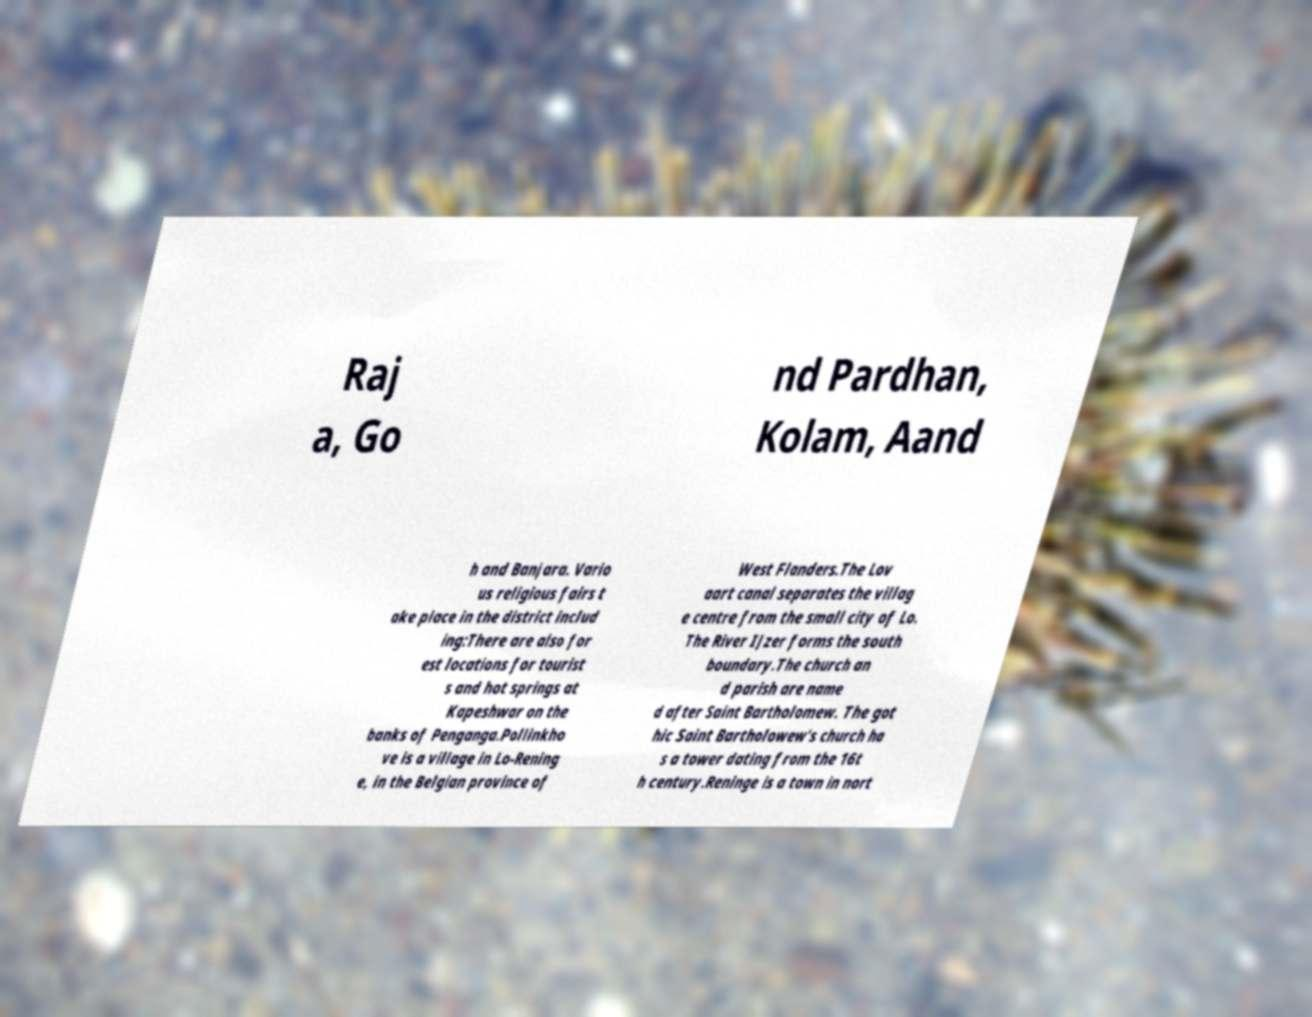Could you assist in decoding the text presented in this image and type it out clearly? Raj a, Go nd Pardhan, Kolam, Aand h and Banjara. Vario us religious fairs t ake place in the district includ ing:There are also for est locations for tourist s and hot springs at Kapeshwar on the banks of Penganga.Pollinkho ve is a village in Lo-Rening e, in the Belgian province of West Flanders.The Lov aart canal separates the villag e centre from the small city of Lo. The River IJzer forms the south boundary.The church an d parish are name d after Saint Bartholomew. The got hic Saint Bartholowew's church ha s a tower dating from the 16t h century.Reninge is a town in nort 